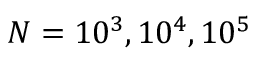Convert formula to latex. <formula><loc_0><loc_0><loc_500><loc_500>N = 1 0 ^ { 3 } , 1 0 ^ { 4 } , 1 0 ^ { 5 }</formula> 